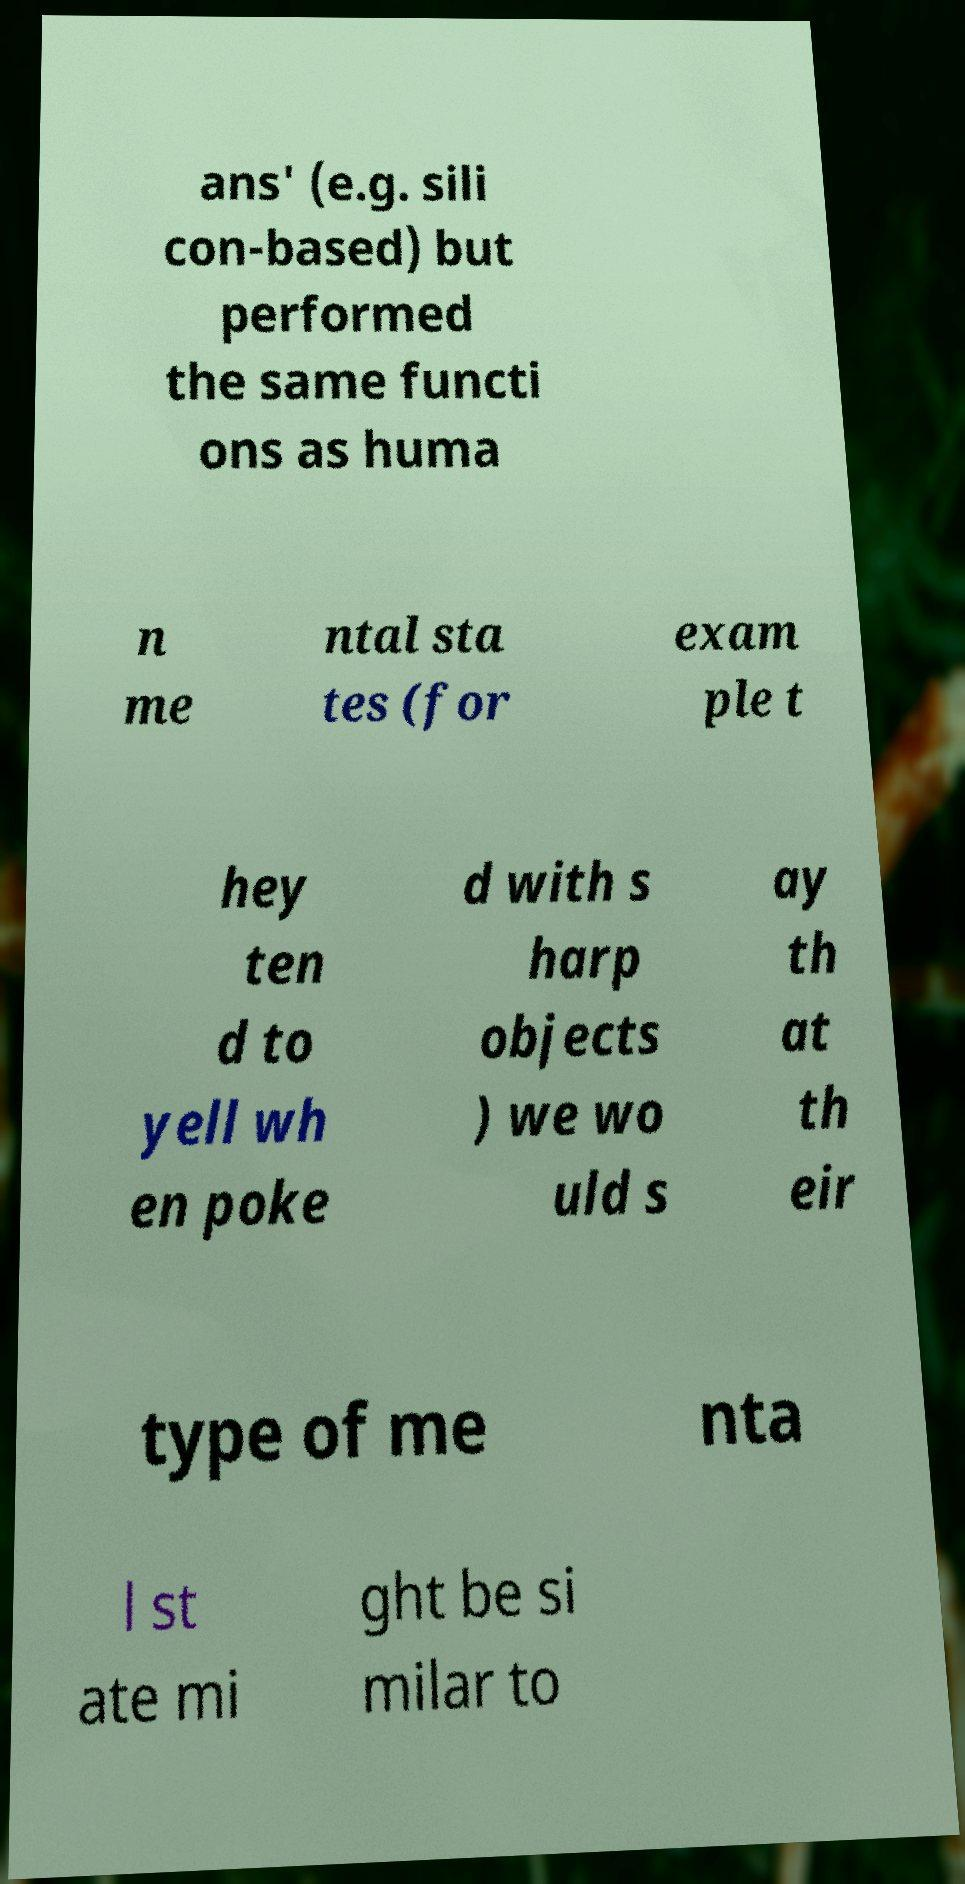Can you accurately transcribe the text from the provided image for me? ans' (e.g. sili con-based) but performed the same functi ons as huma n me ntal sta tes (for exam ple t hey ten d to yell wh en poke d with s harp objects ) we wo uld s ay th at th eir type of me nta l st ate mi ght be si milar to 